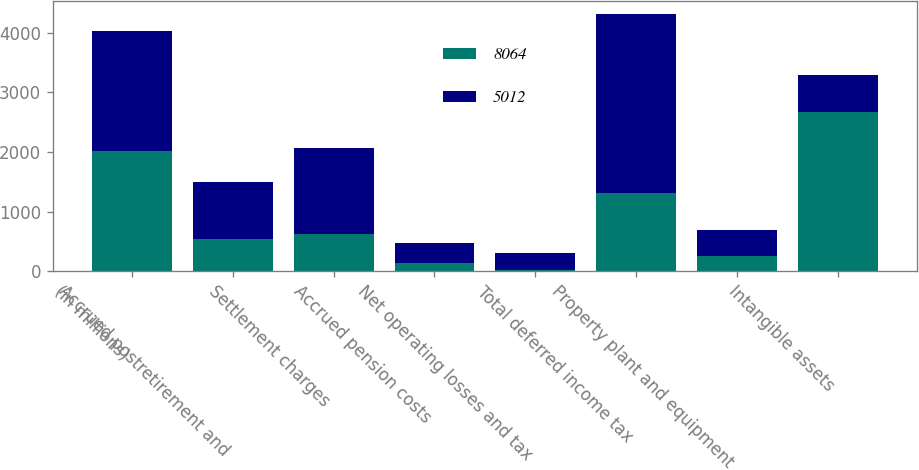Convert chart. <chart><loc_0><loc_0><loc_500><loc_500><stacked_bar_chart><ecel><fcel>(in millions)<fcel>Accrued postretirement and<fcel>Settlement charges<fcel>Accrued pension costs<fcel>Net operating losses and tax<fcel>Total deferred income tax<fcel>Property plant and equipment<fcel>Intangible assets<nl><fcel>8064<fcel>2017<fcel>539<fcel>614<fcel>136<fcel>18<fcel>1307<fcel>261<fcel>2674<nl><fcel>5012<fcel>2016<fcel>952<fcel>1446<fcel>330<fcel>288<fcel>3016<fcel>429<fcel>614<nl></chart> 